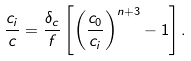<formula> <loc_0><loc_0><loc_500><loc_500>\frac { c _ { i } } { c } = \frac { \delta _ { c } } { f } \left [ \left ( \frac { c _ { 0 } } { c _ { i } } \right ) ^ { n + 3 } - 1 \right ] .</formula> 